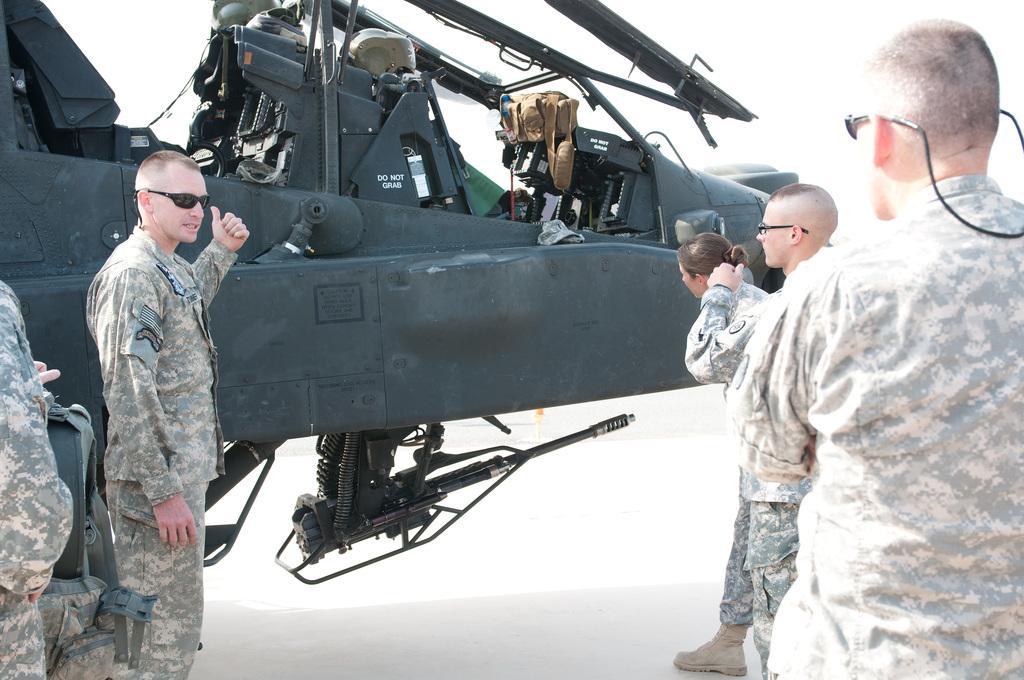Could you give a brief overview of what you see in this image? Soldiers are standing and there is a aircraft. 